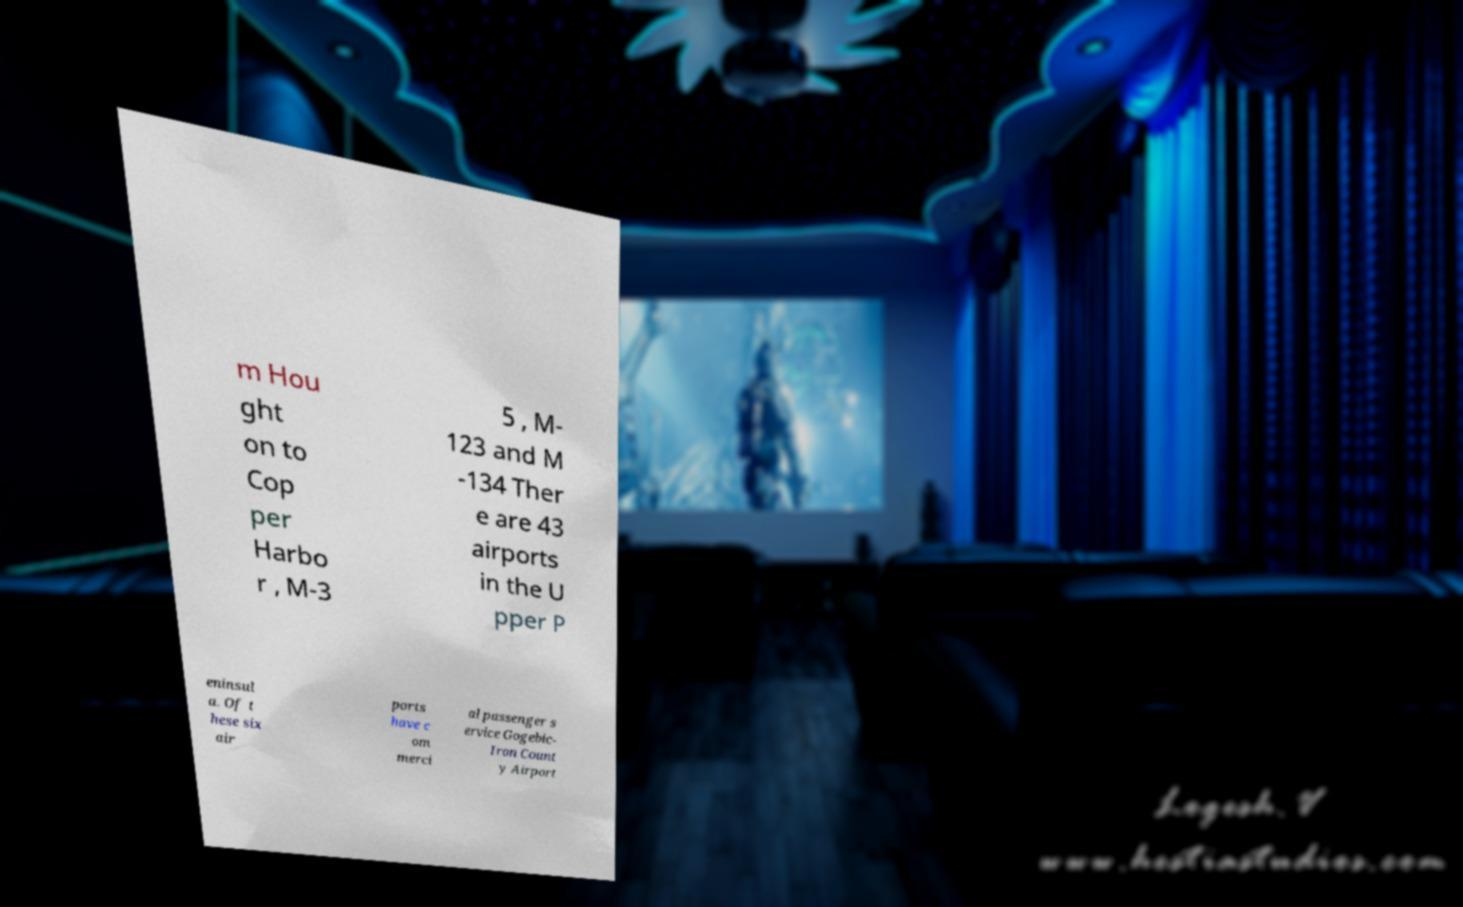Can you read and provide the text displayed in the image?This photo seems to have some interesting text. Can you extract and type it out for me? m Hou ght on to Cop per Harbo r , M-3 5 , M- 123 and M -134 Ther e are 43 airports in the U pper P eninsul a. Of t hese six air ports have c om merci al passenger s ervice Gogebic- Iron Count y Airport 